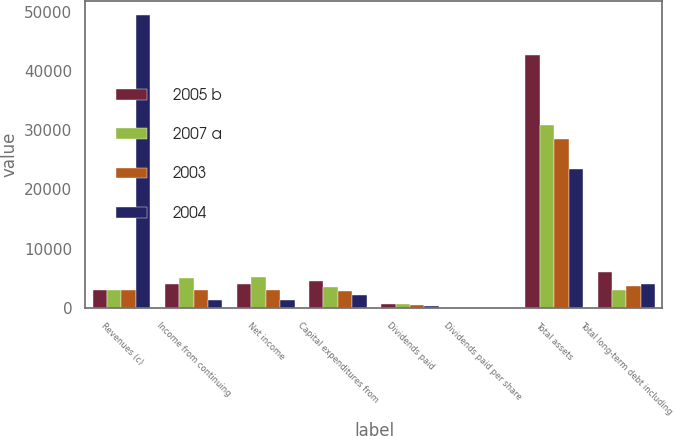Convert chart. <chart><loc_0><loc_0><loc_500><loc_500><stacked_bar_chart><ecel><fcel>Revenues (c)<fcel>Income from continuing<fcel>Net income<fcel>Capital expenditures from<fcel>Dividends paid<fcel>Dividends paid per share<fcel>Total assets<fcel>Total long-term debt including<nl><fcel>2005 b<fcel>3061<fcel>3948<fcel>3956<fcel>4466<fcel>637<fcel>0.92<fcel>42746<fcel>6084<nl><fcel>2007 a<fcel>3061<fcel>4957<fcel>5234<fcel>3433<fcel>547<fcel>0.76<fcel>30831<fcel>3061<nl><fcel>2003<fcel>3061<fcel>3006<fcel>3032<fcel>2796<fcel>436<fcel>0.6<fcel>28498<fcel>3698<nl><fcel>2004<fcel>49465<fcel>1294<fcel>1261<fcel>2141<fcel>348<fcel>0.51<fcel>23423<fcel>4057<nl></chart> 